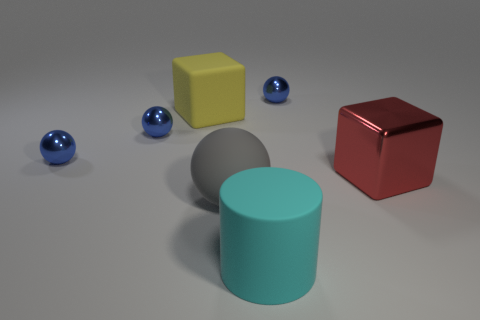What is the material of the red thing that is the same shape as the yellow object?
Your answer should be compact. Metal. What material is the red cube that is the same size as the gray sphere?
Make the answer very short. Metal. What color is the rubber object that is both on the left side of the cyan object and in front of the red metal cube?
Your answer should be very brief. Gray. Are there more large metallic things than spheres?
Your answer should be compact. No. What number of things are small shiny objects or big things in front of the large red shiny thing?
Your response must be concise. 5. Does the cylinder have the same size as the rubber block?
Make the answer very short. Yes. Are there any large cyan matte objects left of the large gray rubber thing?
Your response must be concise. No. There is a metallic object that is behind the big red metallic thing and on the right side of the large cyan rubber object; what is its size?
Keep it short and to the point. Small. What number of things are small metal balls or large blue things?
Give a very brief answer. 3. Do the gray sphere and the blue metallic object to the right of the large cyan object have the same size?
Your answer should be very brief. No. 